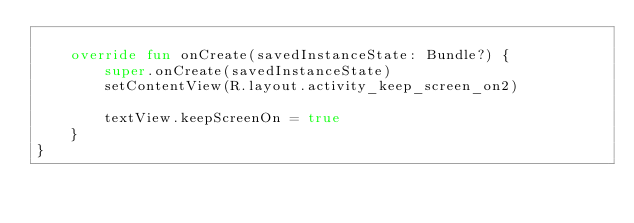Convert code to text. <code><loc_0><loc_0><loc_500><loc_500><_Kotlin_>
    override fun onCreate(savedInstanceState: Bundle?) {
        super.onCreate(savedInstanceState)
        setContentView(R.layout.activity_keep_screen_on2)

        textView.keepScreenOn = true
    }
}
</code> 